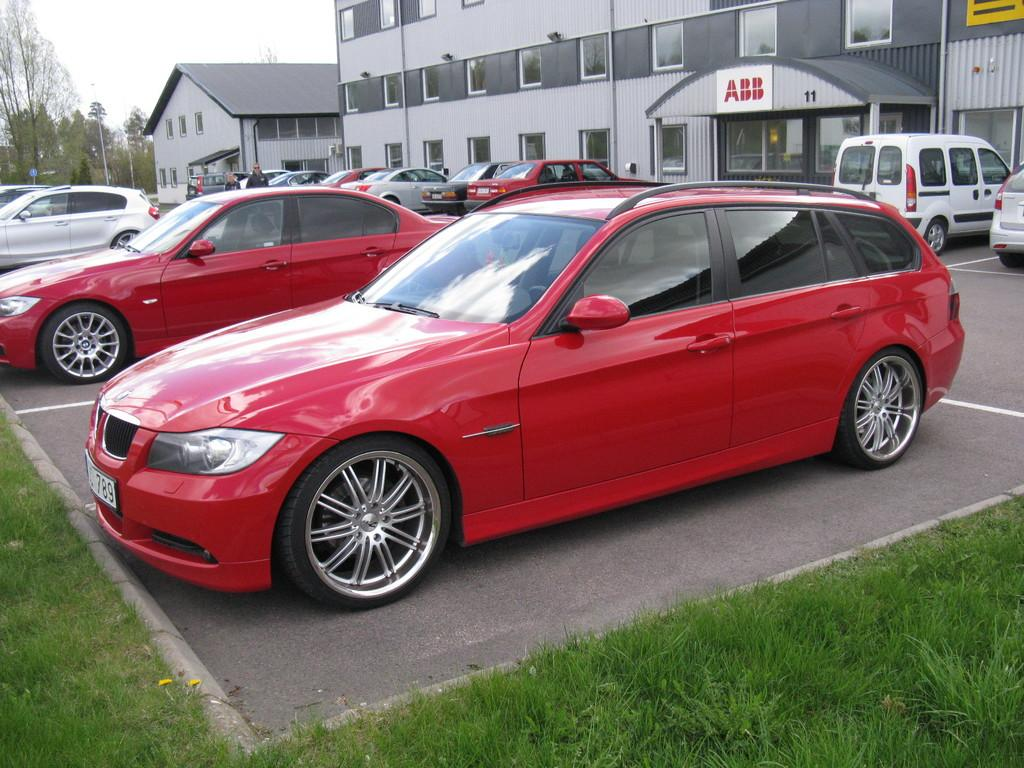What can be seen in the parking area in the image? There are many cars parked in the parking area. What type of surface is the parking area on? There is grass on the ground. What can be seen in the background of the image? There are buildings with windows and trees in the background. What type of skirt is hanging on the tree in the image? There is no skirt present in the image; it features a parking area with cars, grass, buildings, and trees. 